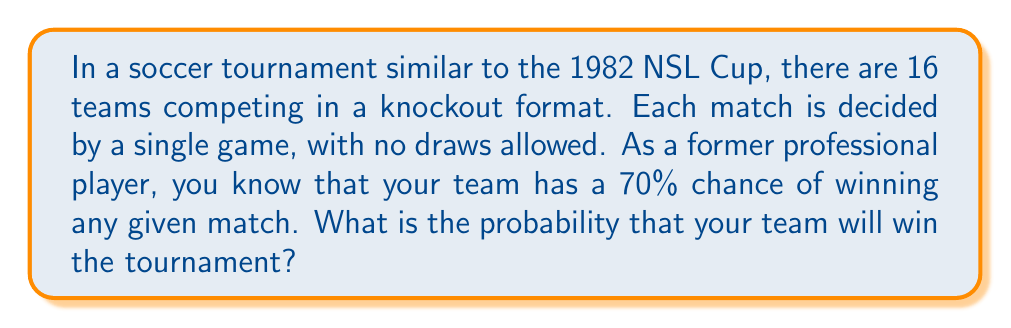Help me with this question. Let's approach this step-by-step:

1) In a knockout tournament with 16 teams, a team needs to win 4 matches to become the champion:
   - Round of 16
   - Quarter-finals
   - Semi-finals
   - Final

2) The probability of winning the tournament is the probability of winning all 4 matches in succession.

3) Given that the probability of winning each match is 70% or 0.7, we can calculate the probability of winning all 4 matches using the multiplication rule of probability:

   $$P(\text{winning tournament}) = 0.7 \times 0.7 \times 0.7 \times 0.7 = 0.7^4$$

4) Let's calculate this:

   $$0.7^4 = 0.2401$$

5) Converting to a percentage:

   $$0.2401 \times 100\% = 24.01\%$$

Therefore, the probability of your team winning the tournament is approximately 24.01%.
Answer: $24.01\%$ 